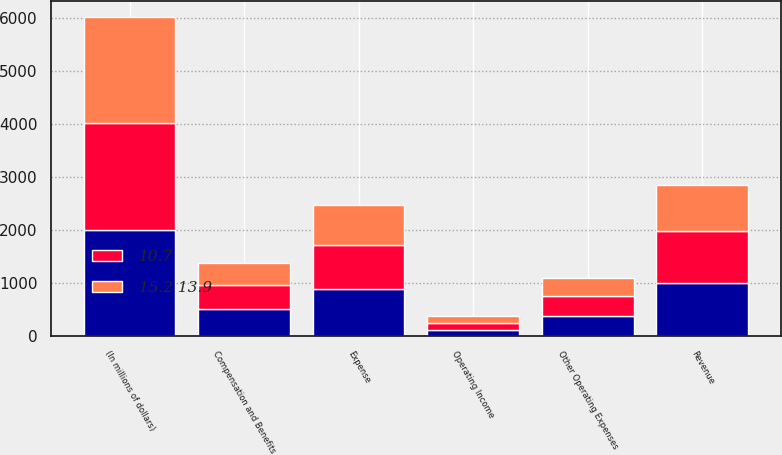<chart> <loc_0><loc_0><loc_500><loc_500><stacked_bar_chart><ecel><fcel>(In millions of dollars)<fcel>Revenue<fcel>Compensation and Benefits<fcel>Other Operating Expenses<fcel>Expense<fcel>Operating Income<nl><fcel>nan<fcel>2007<fcel>995<fcel>506<fcel>383<fcel>889<fcel>106<nl><fcel>10.7<fcel>2006<fcel>979<fcel>466<fcel>364<fcel>830<fcel>149<nl><fcel>15.2 13.9<fcel>2005<fcel>872<fcel>406<fcel>345<fcel>751<fcel>121<nl></chart> 